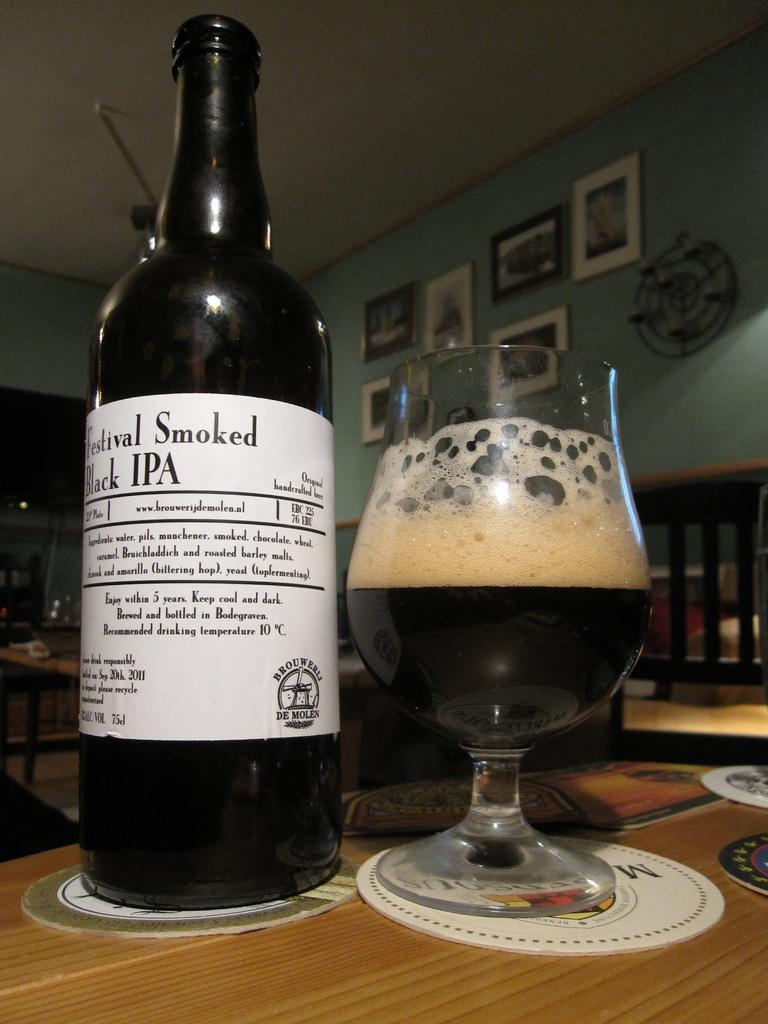<image>
Summarize the visual content of the image. Some wine with the title Festival Smoked on the label 